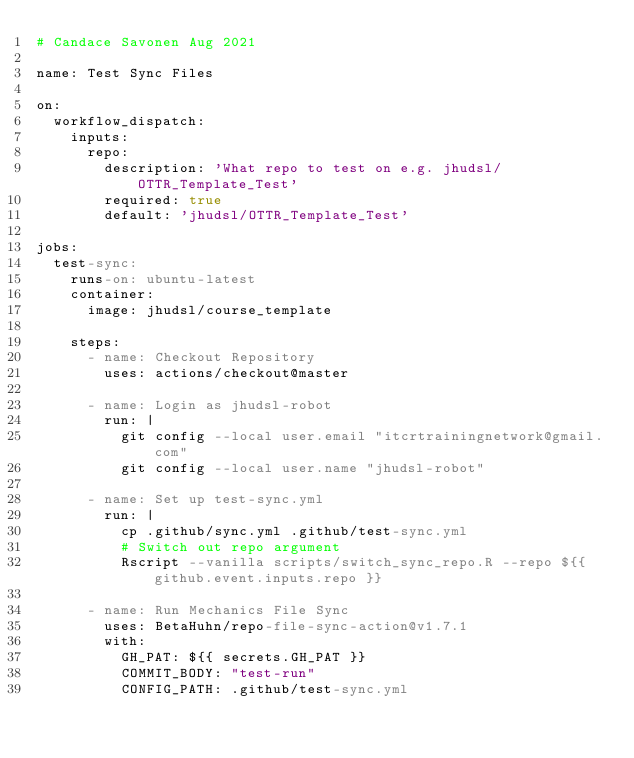<code> <loc_0><loc_0><loc_500><loc_500><_YAML_># Candace Savonen Aug 2021

name: Test Sync Files

on:
  workflow_dispatch:
    inputs:
      repo:
        description: 'What repo to test on e.g. jhudsl/OTTR_Template_Test'
        required: true
        default: 'jhudsl/OTTR_Template_Test'

jobs:
  test-sync:
    runs-on: ubuntu-latest
    container:
      image: jhudsl/course_template

    steps:
      - name: Checkout Repository
        uses: actions/checkout@master

      - name: Login as jhudsl-robot
        run: |
          git config --local user.email "itcrtrainingnetwork@gmail.com"
          git config --local user.name "jhudsl-robot"

      - name: Set up test-sync.yml
        run: |
          cp .github/sync.yml .github/test-sync.yml
          # Switch out repo argument
          Rscript --vanilla scripts/switch_sync_repo.R --repo ${{ github.event.inputs.repo }}

      - name: Run Mechanics File Sync
        uses: BetaHuhn/repo-file-sync-action@v1.7.1
        with:
          GH_PAT: ${{ secrets.GH_PAT }}
          COMMIT_BODY: "test-run"
          CONFIG_PATH: .github/test-sync.yml
</code> 